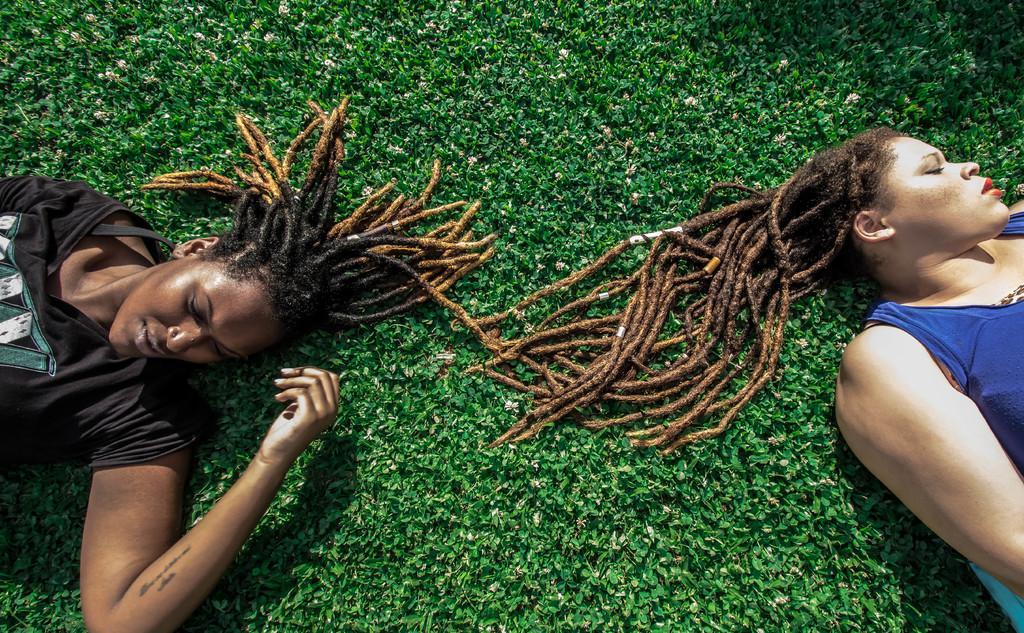Please provide a concise description of this image. In this image, we can see two people lying on the ground. 